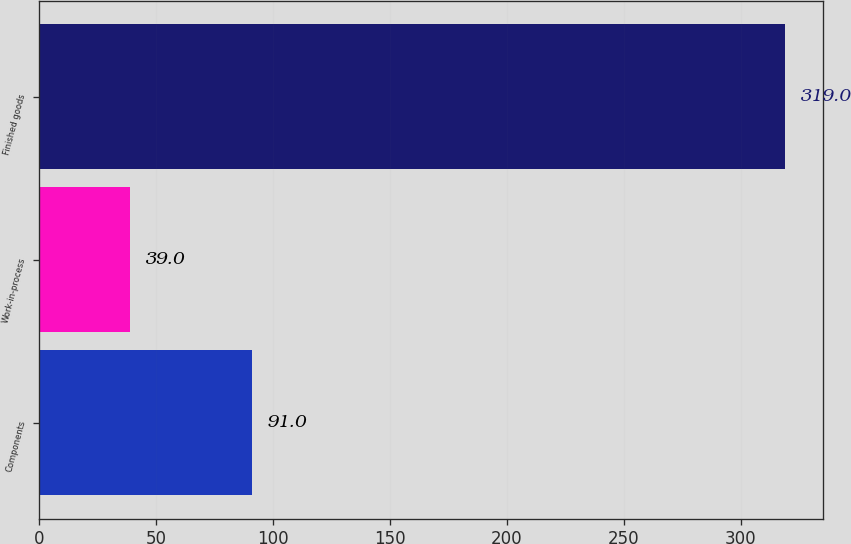Convert chart to OTSL. <chart><loc_0><loc_0><loc_500><loc_500><bar_chart><fcel>Components<fcel>Work-in-process<fcel>Finished goods<nl><fcel>91<fcel>39<fcel>319<nl></chart> 